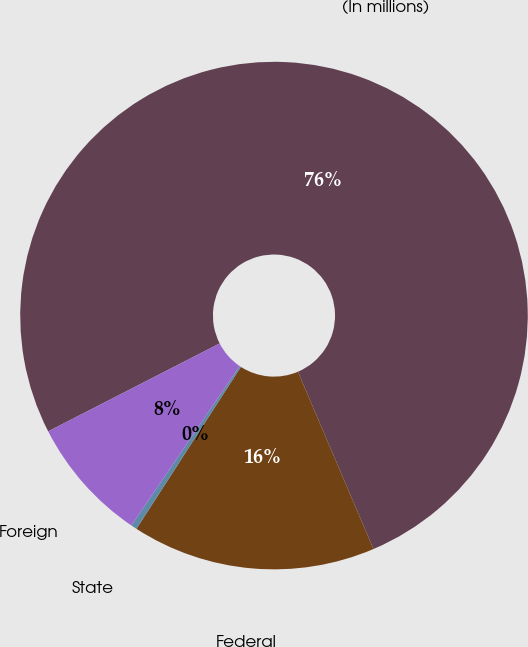Convert chart to OTSL. <chart><loc_0><loc_0><loc_500><loc_500><pie_chart><fcel>(In millions)<fcel>Federal<fcel>State<fcel>Foreign<nl><fcel>76.13%<fcel>15.53%<fcel>0.38%<fcel>7.96%<nl></chart> 